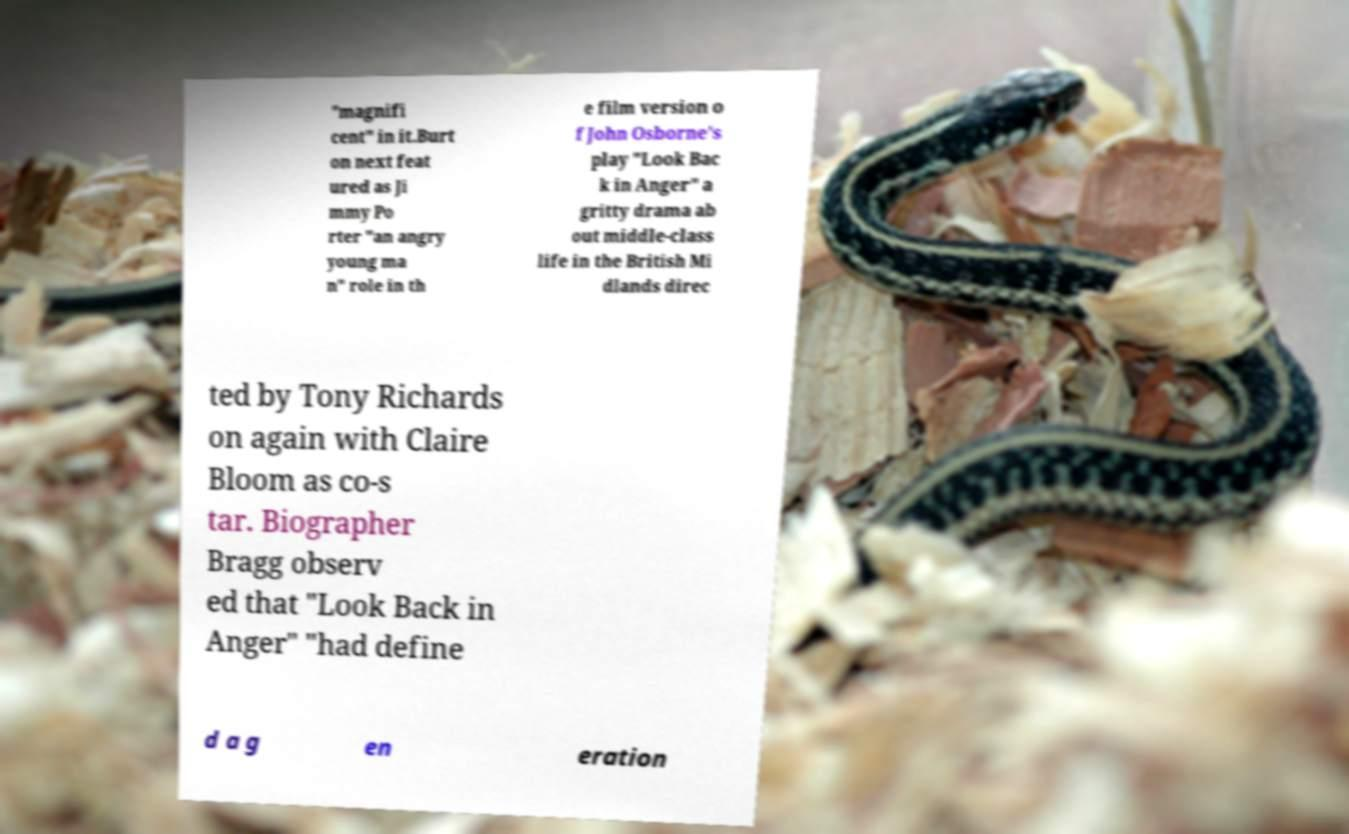Please identify and transcribe the text found in this image. "magnifi cent" in it.Burt on next feat ured as Ji mmy Po rter "an angry young ma n" role in th e film version o f John Osborne's play "Look Bac k in Anger" a gritty drama ab out middle-class life in the British Mi dlands direc ted by Tony Richards on again with Claire Bloom as co-s tar. Biographer Bragg observ ed that "Look Back in Anger" "had define d a g en eration 